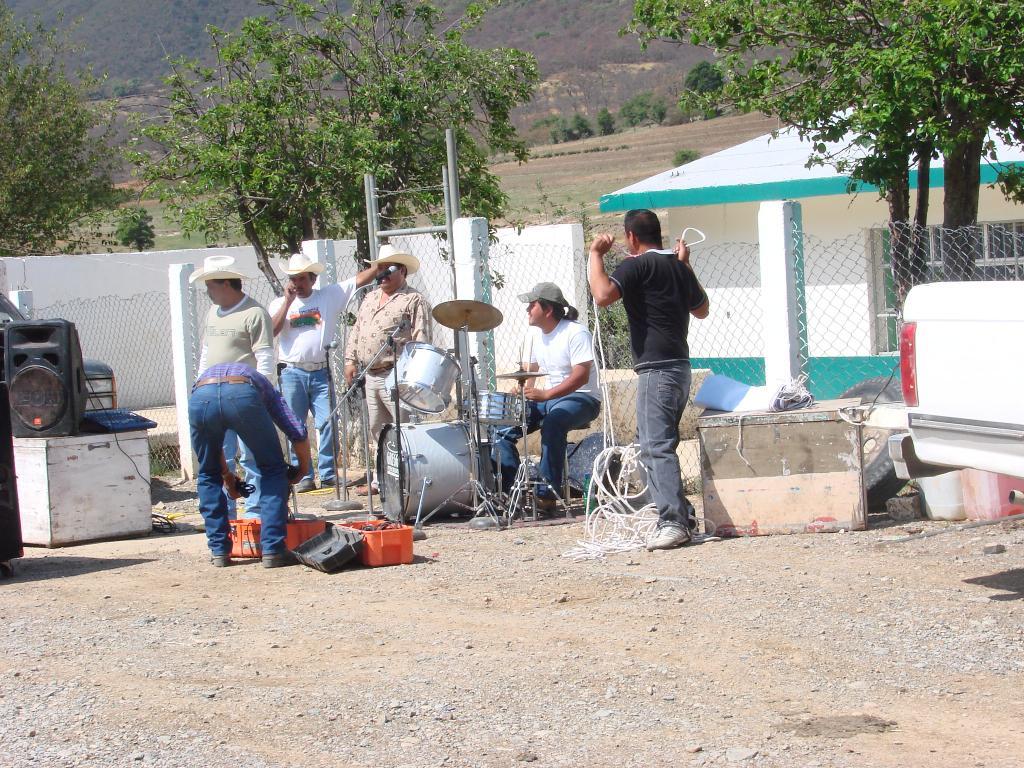How would you summarize this image in a sentence or two? In this image in the center there are group of people some of them are sitting and some of them are standing and on the background there are mountains and trees are there. And on the right side there is a fence and one house is there and on the left side there is wall and one sound system is there on the table and in the center there are some drums. 